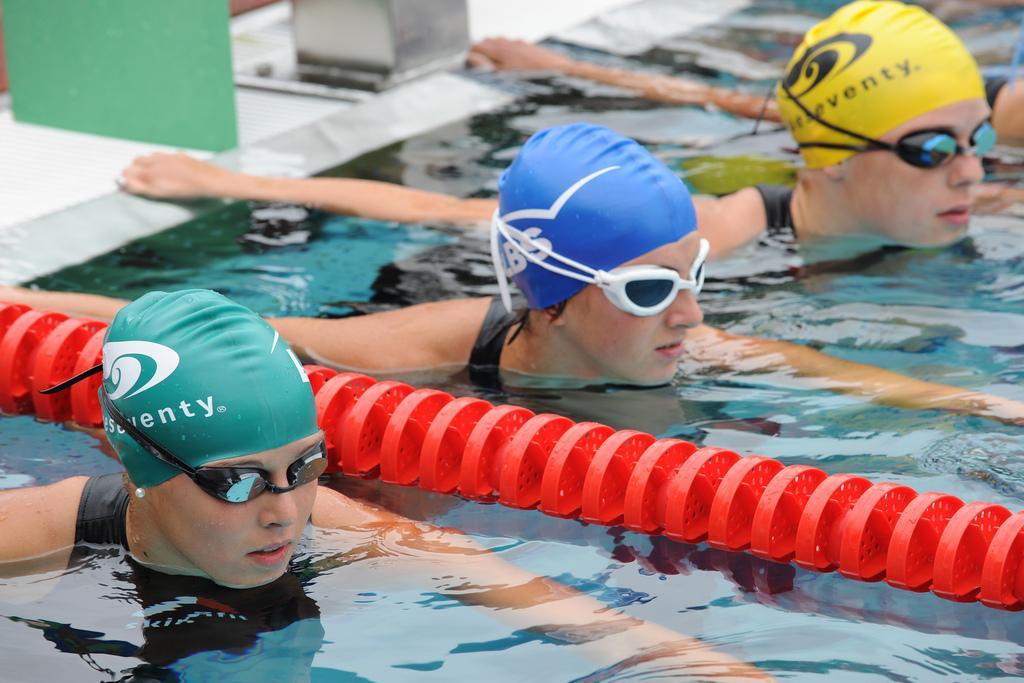Can you describe this image briefly? In this image we can see few persons are in the water partially and all of them have caps on their heads and swimming glasses to their eyes and red color object on the water. In the background we can see objects on the platform. 